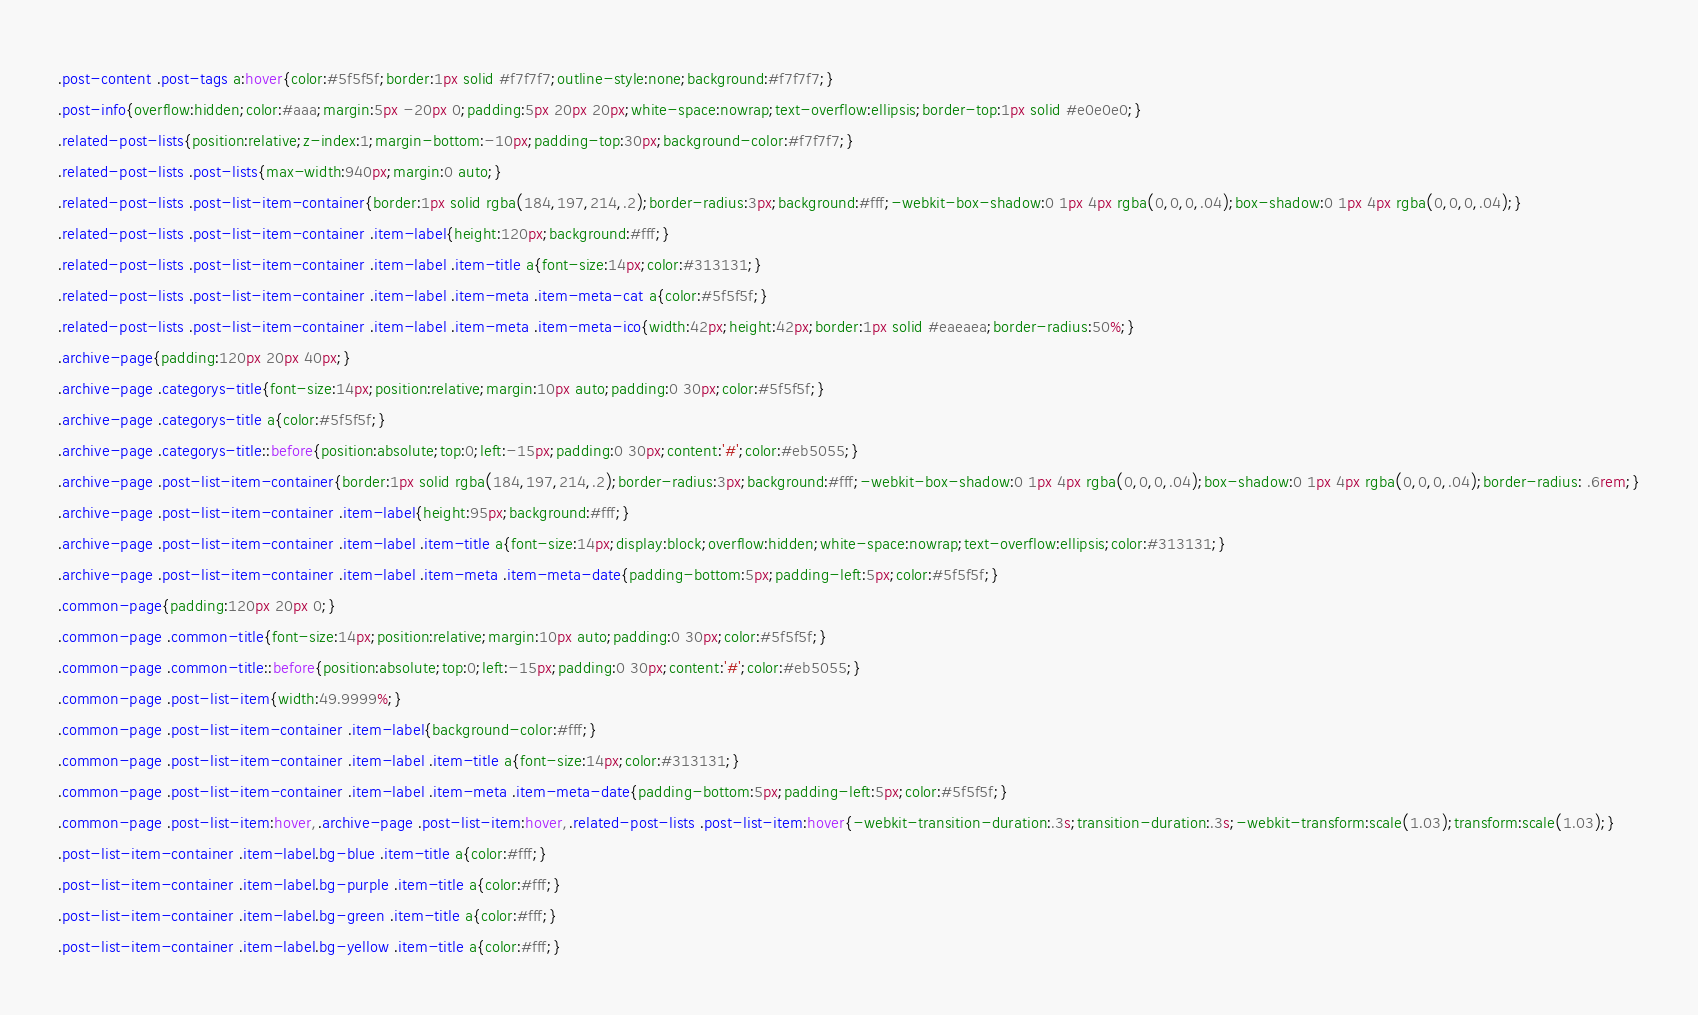<code> <loc_0><loc_0><loc_500><loc_500><_CSS_>.post-content .post-tags a:hover{color:#5f5f5f;border:1px solid #f7f7f7;outline-style:none;background:#f7f7f7;}
.post-info{overflow:hidden;color:#aaa;margin:5px -20px 0;padding:5px 20px 20px;white-space:nowrap;text-overflow:ellipsis;border-top:1px solid #e0e0e0;}
.related-post-lists{position:relative;z-index:1;margin-bottom:-10px;padding-top:30px;background-color:#f7f7f7;}
.related-post-lists .post-lists{max-width:940px;margin:0 auto;}
.related-post-lists .post-list-item-container{border:1px solid rgba(184,197,214,.2);border-radius:3px;background:#fff;-webkit-box-shadow:0 1px 4px rgba(0,0,0,.04);box-shadow:0 1px 4px rgba(0,0,0,.04);}
.related-post-lists .post-list-item-container .item-label{height:120px;background:#fff;}
.related-post-lists .post-list-item-container .item-label .item-title a{font-size:14px;color:#313131;}
.related-post-lists .post-list-item-container .item-label .item-meta .item-meta-cat a{color:#5f5f5f;}
.related-post-lists .post-list-item-container .item-label .item-meta .item-meta-ico{width:42px;height:42px;border:1px solid #eaeaea;border-radius:50%;}
.archive-page{padding:120px 20px 40px;}
.archive-page .categorys-title{font-size:14px;position:relative;margin:10px auto;padding:0 30px;color:#5f5f5f;}
.archive-page .categorys-title a{color:#5f5f5f;}
.archive-page .categorys-title::before{position:absolute;top:0;left:-15px;padding:0 30px;content:'#';color:#eb5055;}
.archive-page .post-list-item-container{border:1px solid rgba(184,197,214,.2);border-radius:3px;background:#fff;-webkit-box-shadow:0 1px 4px rgba(0,0,0,.04);box-shadow:0 1px 4px rgba(0,0,0,.04);border-radius: .6rem;}
.archive-page .post-list-item-container .item-label{height:95px;background:#fff;}
.archive-page .post-list-item-container .item-label .item-title a{font-size:14px;display:block;overflow:hidden;white-space:nowrap;text-overflow:ellipsis;color:#313131;}
.archive-page .post-list-item-container .item-label .item-meta .item-meta-date{padding-bottom:5px;padding-left:5px;color:#5f5f5f;}
.common-page{padding:120px 20px 0;}
.common-page .common-title{font-size:14px;position:relative;margin:10px auto;padding:0 30px;color:#5f5f5f;}
.common-page .common-title::before{position:absolute;top:0;left:-15px;padding:0 30px;content:'#';color:#eb5055;}
.common-page .post-list-item{width:49.9999%;}
.common-page .post-list-item-container .item-label{background-color:#fff;}
.common-page .post-list-item-container .item-label .item-title a{font-size:14px;color:#313131;}
.common-page .post-list-item-container .item-label .item-meta .item-meta-date{padding-bottom:5px;padding-left:5px;color:#5f5f5f;}
.common-page .post-list-item:hover,.archive-page .post-list-item:hover,.related-post-lists .post-list-item:hover{-webkit-transition-duration:.3s;transition-duration:.3s;-webkit-transform:scale(1.03);transform:scale(1.03);}
.post-list-item-container .item-label.bg-blue .item-title a{color:#fff;}
.post-list-item-container .item-label.bg-purple .item-title a{color:#fff;}
.post-list-item-container .item-label.bg-green .item-title a{color:#fff;}
.post-list-item-container .item-label.bg-yellow .item-title a{color:#fff;}</code> 